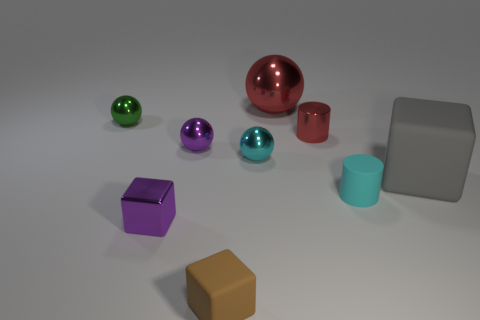Subtract 1 spheres. How many spheres are left? 3 Add 1 large blue rubber spheres. How many objects exist? 10 Subtract all balls. How many objects are left? 5 Add 2 red metal things. How many red metal things exist? 4 Subtract 1 brown blocks. How many objects are left? 8 Subtract all green shiny balls. Subtract all metal spheres. How many objects are left? 4 Add 6 brown rubber things. How many brown rubber things are left? 7 